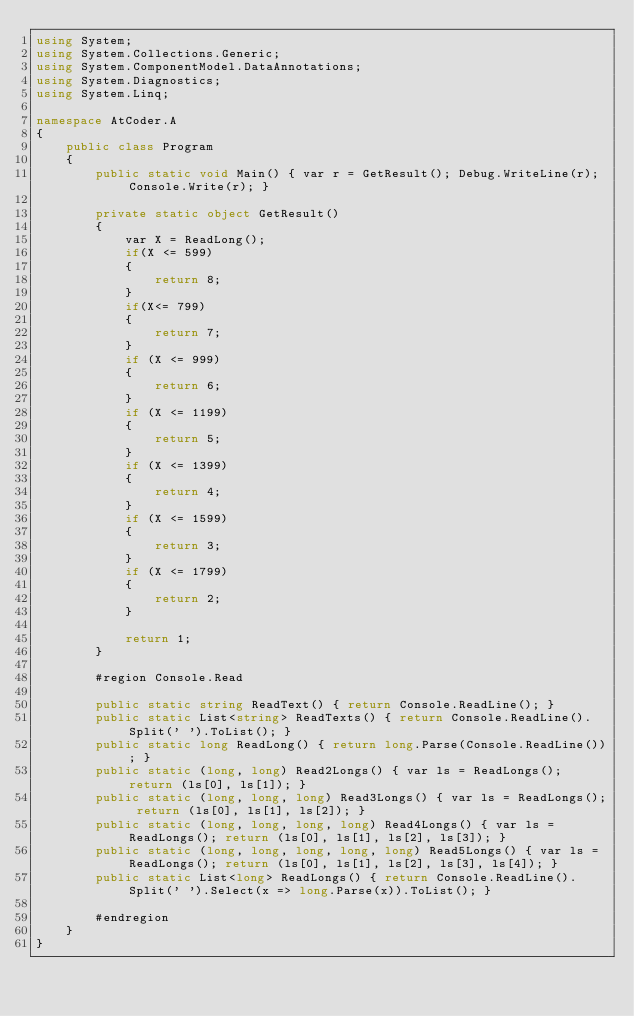Convert code to text. <code><loc_0><loc_0><loc_500><loc_500><_C#_>using System;
using System.Collections.Generic;
using System.ComponentModel.DataAnnotations;
using System.Diagnostics;
using System.Linq;

namespace AtCoder.A
{
    public class Program
    {
        public static void Main() { var r = GetResult(); Debug.WriteLine(r); Console.Write(r); }

        private static object GetResult()
        {
            var X = ReadLong();
            if(X <= 599)
            {
                return 8;
            }
            if(X<= 799)
            {
                return 7;
            }
            if (X <= 999)
            {
                return 6;
            }
            if (X <= 1199)
            {
                return 5;
            }
            if (X <= 1399)
            {
                return 4;
            }
            if (X <= 1599)
            {
                return 3;
            }
            if (X <= 1799)
            {
                return 2;
            }

            return 1;
        }

        #region Console.Read

        public static string ReadText() { return Console.ReadLine(); }
        public static List<string> ReadTexts() { return Console.ReadLine().Split(' ').ToList(); }
        public static long ReadLong() { return long.Parse(Console.ReadLine()); }
        public static (long, long) Read2Longs() { var ls = ReadLongs(); return (ls[0], ls[1]); }
        public static (long, long, long) Read3Longs() { var ls = ReadLongs(); return (ls[0], ls[1], ls[2]); }
        public static (long, long, long, long) Read4Longs() { var ls = ReadLongs(); return (ls[0], ls[1], ls[2], ls[3]); }
        public static (long, long, long, long, long) Read5Longs() { var ls = ReadLongs(); return (ls[0], ls[1], ls[2], ls[3], ls[4]); }
        public static List<long> ReadLongs() { return Console.ReadLine().Split(' ').Select(x => long.Parse(x)).ToList(); }

        #endregion
    }
}
</code> 